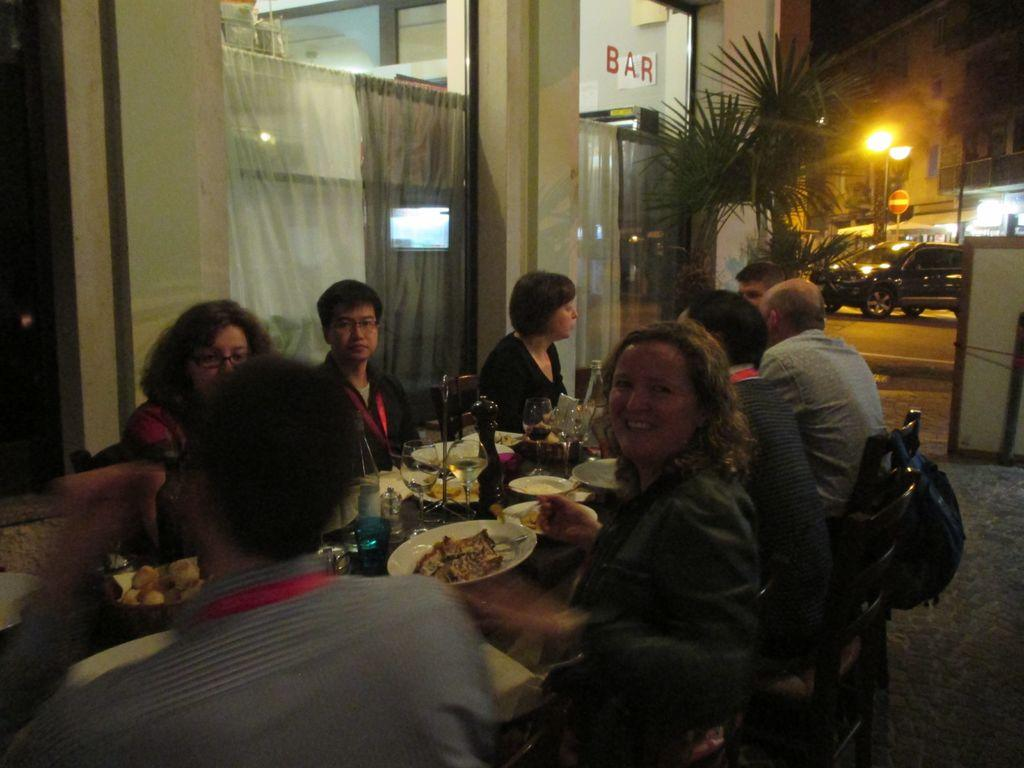What are the people in the image doing? The people in the image are sitting on chairs. How are the chairs arranged in the image? The chairs are arranged around a table. What can be found on the table in the image? There are things on the table. What type of window treatment is visible in the image? There are two curtains visible in the image. What can be seen in the background of the image? There is a car in the background of the image. What type of seed is being planted by the visitor in the image? There is no visitor or seed present in the image. 